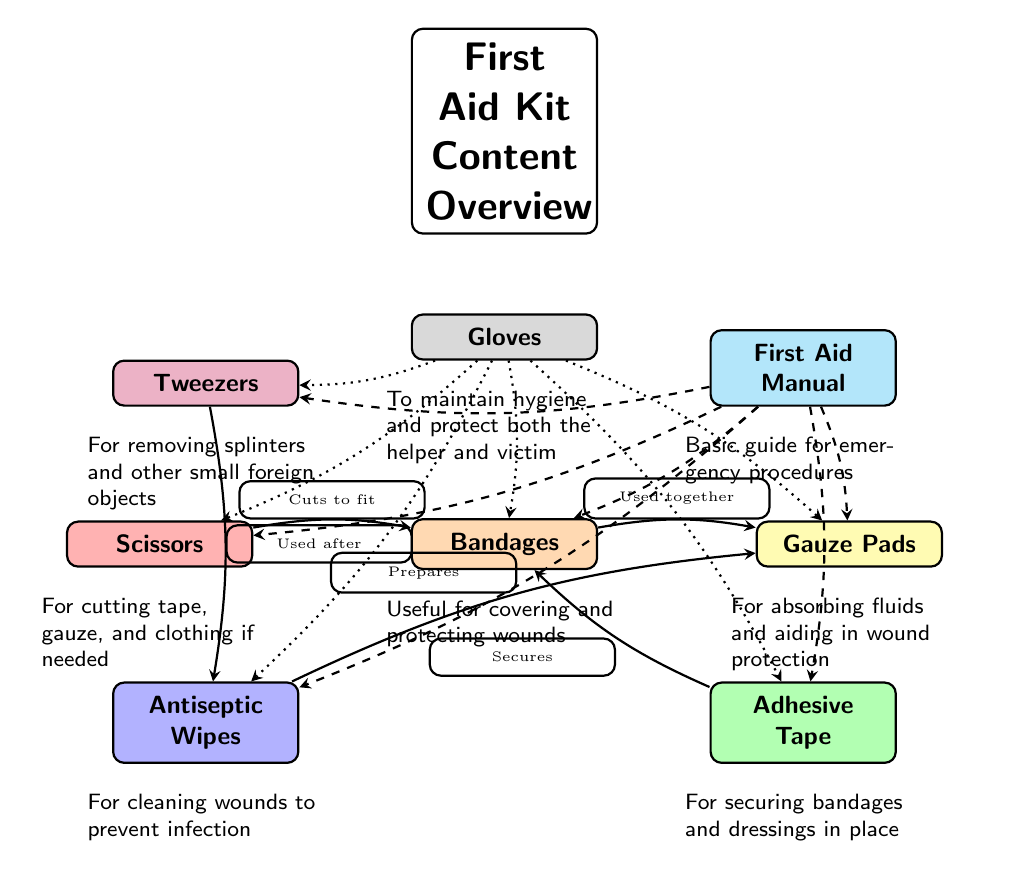What items are included in the first aid kit? The diagram lists eight items: Bandages, Gauze Pads, Adhesive Tape, Antiseptic Wipes, Scissors, Tweezers, Gloves, and First Aid Manual.
Answer: Bandages, Gauze Pads, Adhesive Tape, Antiseptic Wipes, Scissors, Tweezers, Gloves, First Aid Manual How many items are in the first aid kit? There are eight distinct items displayed in the diagram, each represented as a node.
Answer: 8 What does Adhesive Tape do? The description below the Adhesive Tape node states that it is for securing bandages and dressings in place, highlighting its function.
Answer: Secures bandages and dressings Which item is used for cleaning wounds? The diagram specifically describes Antiseptic Wipes as being used for cleaning wounds to prevent infection, making it clear that this item serves that purpose.
Answer: Antiseptic Wipes What item is used after cleaning the wound? The diagram shows a connection from Antiseptic Wipes to Tweezers, indicating that Tweezers are used after cleaning with the wipes to remove splinters or foreign objects.
Answer: Tweezers Which two items are directly connected by a solid edge? The solid edges link several items, but one clear stand-out connection is between Bandages and Gauze Pads, which states that they are used together.
Answer: Bandages, Gauze Pads What is the purpose of the First Aid Manual? The diagram provides a description that states the First Aid Manual is a basic guide for emergency procedures, thus clarifying its intended use within the kit.
Answer: Basic guide for emergency procedures How do Scissors relate to Bandages? The diagram has a labeled edge that indicates Scissors are used to cut the Bandages to fit appropriately, demonstrating the relationship in functionality.
Answer: Cuts to fit 